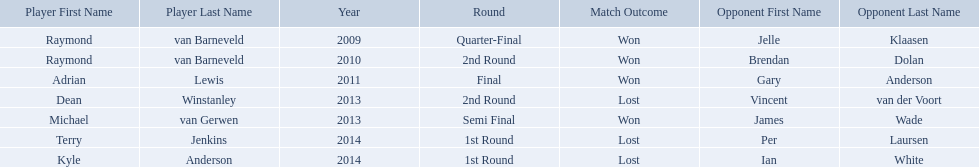Who are all the players? Raymond van Barneveld, Raymond van Barneveld, Adrian Lewis, Dean Winstanley, Michael van Gerwen, Terry Jenkins, Kyle Anderson. When did they play? 2009, 2010, 2011, 2013, 2013, 2014, 2014. And which player played in 2011? Adrian Lewis. Did terry jenkins win in 2014? Terry Jenkins, Lost. If terry jenkins lost who won? Per Laursen. What are all the years? 2009, 2010, 2011, 2013, 2013, 2014, 2014. Of these, which ones are 2014? 2014, 2014. Of these dates which one is associated with a player other than kyle anderson? 2014. What is the player name associated with this year? Terry Jenkins. Who are the players at the pdc world darts championship? Raymond van Barneveld, Raymond van Barneveld, Adrian Lewis, Dean Winstanley, Michael van Gerwen, Terry Jenkins, Kyle Anderson. When did kyle anderson lose? 2014. Which other players lost in 2014? Terry Jenkins. 